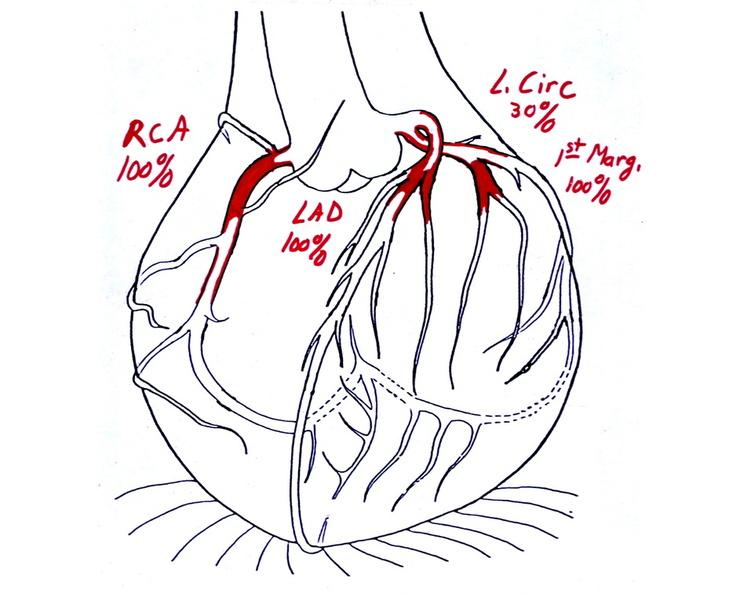what is present?
Answer the question using a single word or phrase. Cardiovascular 